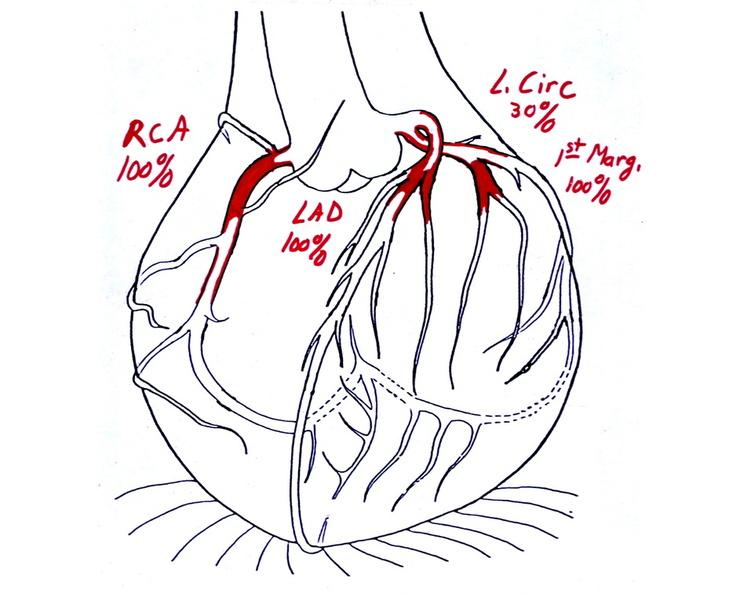what is present?
Answer the question using a single word or phrase. Cardiovascular 